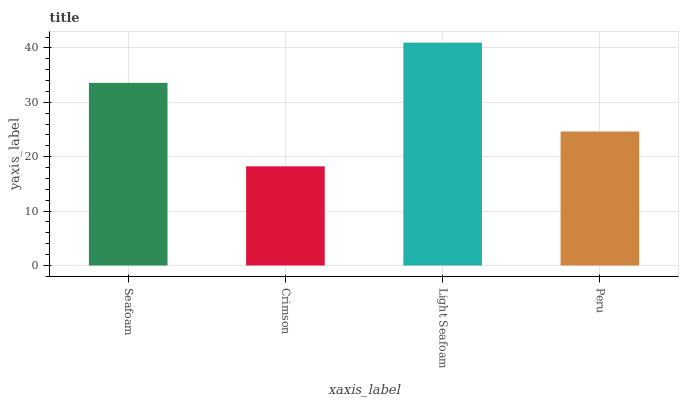Is Light Seafoam the minimum?
Answer yes or no. No. Is Crimson the maximum?
Answer yes or no. No. Is Light Seafoam greater than Crimson?
Answer yes or no. Yes. Is Crimson less than Light Seafoam?
Answer yes or no. Yes. Is Crimson greater than Light Seafoam?
Answer yes or no. No. Is Light Seafoam less than Crimson?
Answer yes or no. No. Is Seafoam the high median?
Answer yes or no. Yes. Is Peru the low median?
Answer yes or no. Yes. Is Crimson the high median?
Answer yes or no. No. Is Light Seafoam the low median?
Answer yes or no. No. 